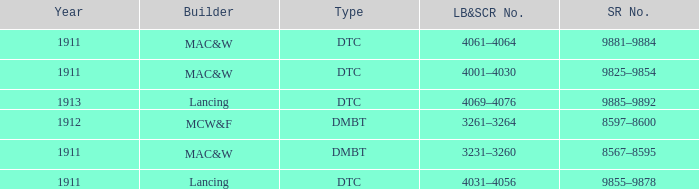Help me parse the entirety of this table. {'header': ['Year', 'Builder', 'Type', 'LB&SCR No.', 'SR No.'], 'rows': [['1911', 'MAC&W', 'DTC', '4061–4064', '9881–9884'], ['1911', 'MAC&W', 'DTC', '4001–4030', '9825–9854'], ['1913', 'Lancing', 'DTC', '4069–4076', '9885–9892'], ['1912', 'MCW&F', 'DMBT', '3261–3264', '8597–8600'], ['1911', 'MAC&W', 'DMBT', '3231–3260', '8567–8595'], ['1911', 'Lancing', 'DTC', '4031–4056', '9855–9878']]} Name the LB&SCR number that has SR number of 8597–8600 3261–3264. 